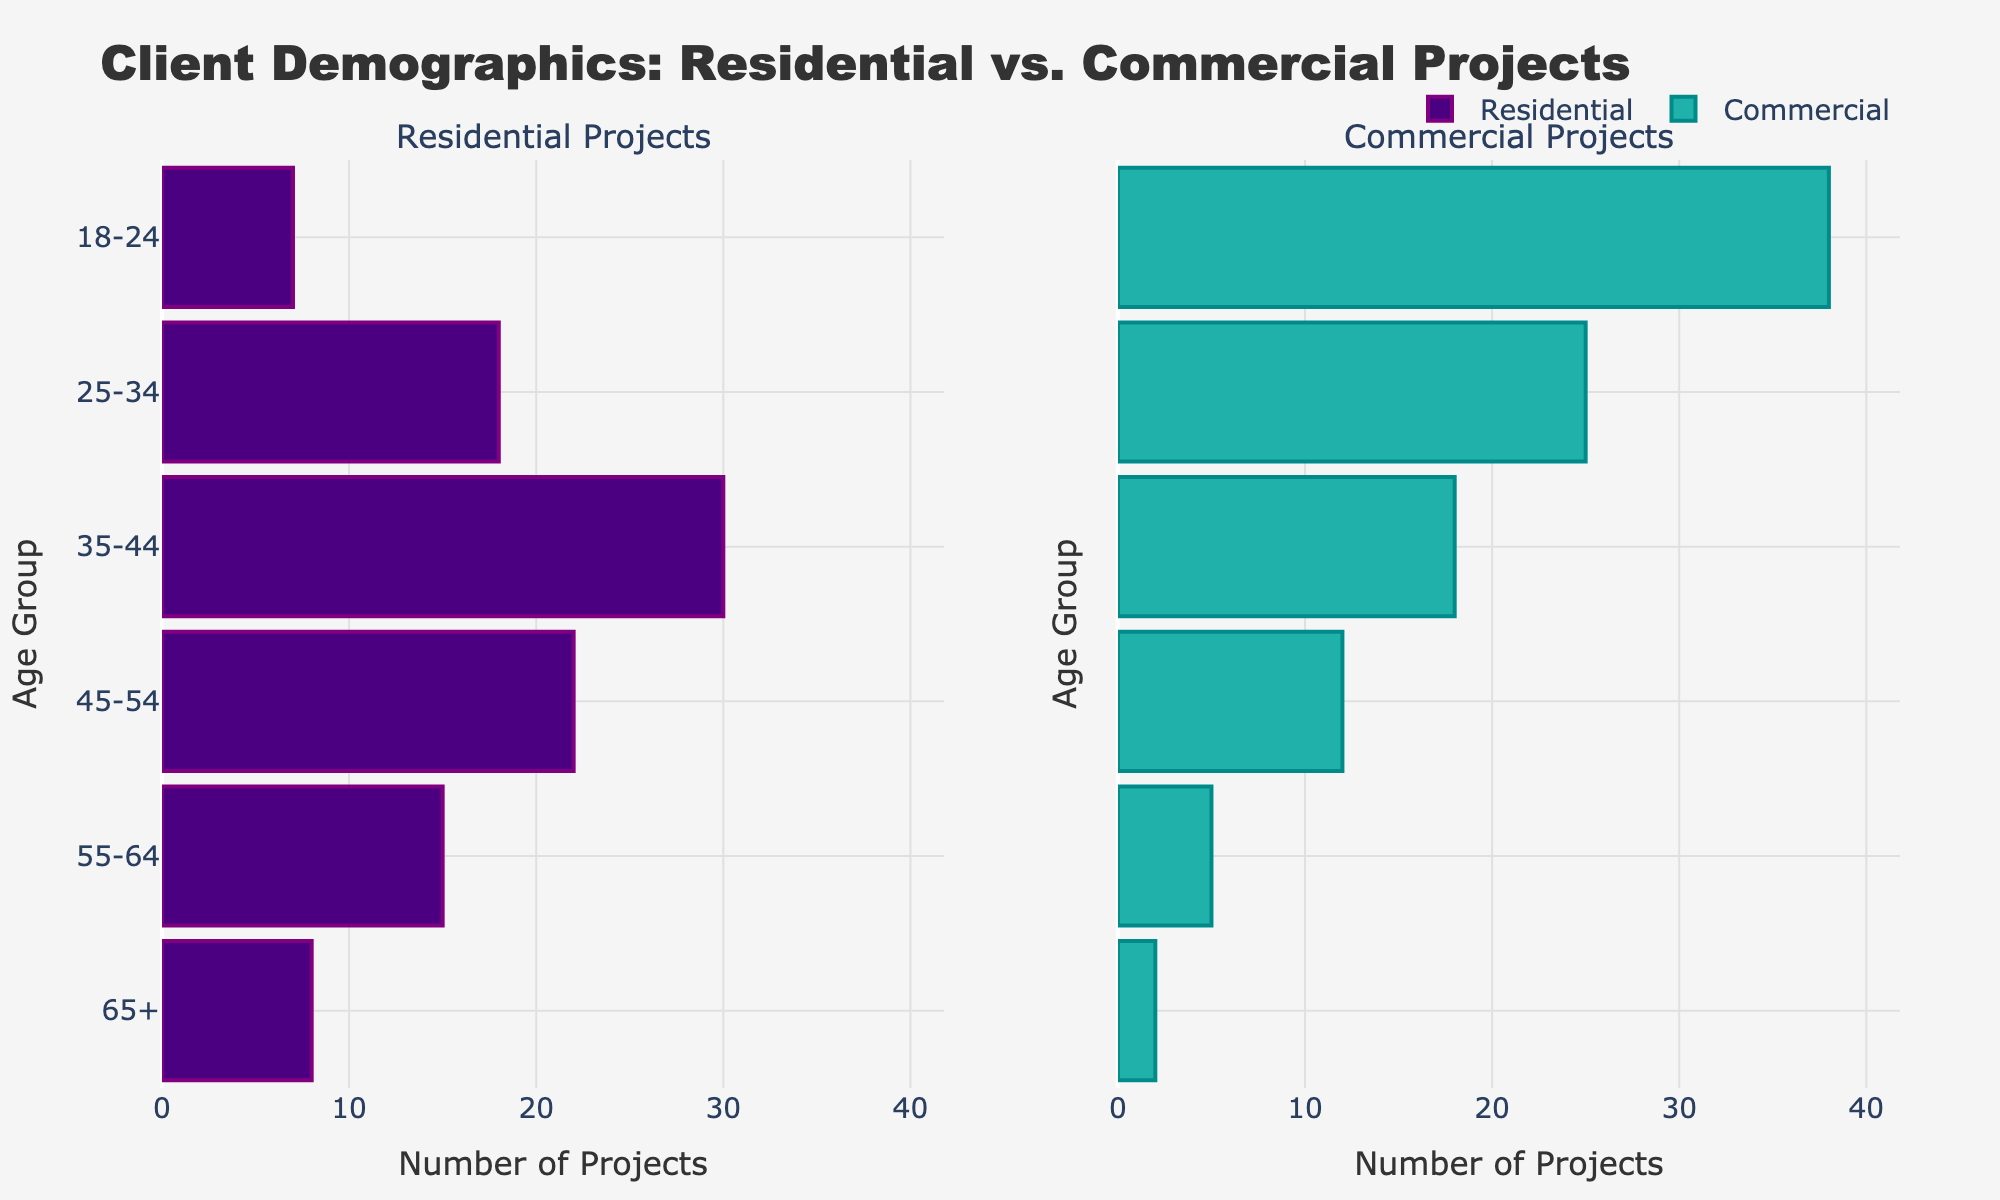what is the title of the plot? The title of the plot is displayed at the top of the figure.
Answer: Client Demographics: Residential vs. Commercial Projects How many age groups are represented on the plot? The age ranges or groups are denoted on the y-axis of the figure. We count the distinct labels along this axis.
Answer: 6 In the 25-34 age group, which project type has more clients? Look at the 25-34 age group row and compare the lengths of the bars for Residential and Commercial projects.
Answer: Commercial What's the total number of residential projects for clients aged 65+ and 55-64? To find the total, sum the number of residential projects for the 65+ and 55-64 age groups. 8 (65+) + 15 (55-64) = 23.
Answer: 23 What is the age group with the highest number of clients in commercial projects? Check the commercial projects subplot and identify the bar with the highest value.
Answer: 18-24 How does the number of clients aged 45-54 in commercial projects compare to those in residential projects? Examine both subplots for the 45-54 age group and compare the lengths of the bars.
Answer: Residential projects have more clients What is the difference in the number of clients aged 35-44 between residential and commercial projects? Subtract the number of commercial projects' clients from residential in the 35-44 age group: 30 (residential) - 18 (commercial).
Answer: 12 Which age group has the least number of residential project clients? Check the smallest bar in the Residential Projects subplot.
Answer: 18-24 For age group 18-24, how many more clients are involved in commercial projects compared to residential projects? Subtract the number of residential projects' clients from commercial in the 18-24 age group: 38 (commercial) - 7 (residential).
Answer: 31 